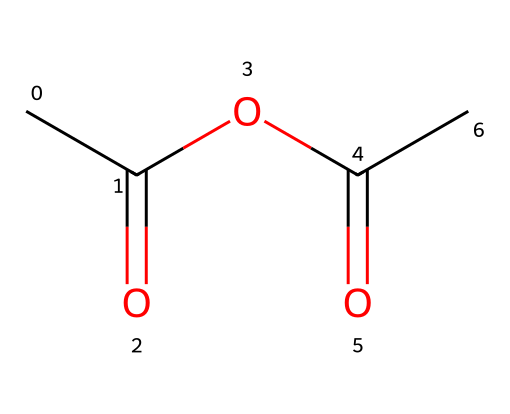What is the molecular formula of acetic anhydride? The chemical is represented by the provided SMILES, which shows there are 4 carbon atoms (C), 6 hydrogen atoms (H), and 3 oxygen atoms (O) present. The formula can be determined as C4H6O3.
Answer: C4H6O3 How many carbon atoms are in acetic anhydride? The SMILES structure indicates there are 4 carbon atoms (C) present in the chemical, as counted from the structure.
Answer: 4 What type of chemical bond is primarily observed in acetic anhydride? The structure shows that acetic anhydride contains both single and double bonds (specifically C=O and C-C). The most significant bond type in this chemical is the carbonyl bond (C=O).
Answer: carbonyl bond What is the significance of the functional group present in acetic anhydride? Acetic anhydride consists of an anhydride functional group, which is characterized by the presence of two acyl groups (RCO) bonded to the same oxygen atom. This functional group's presence is key for its reactivity, particularly in acylation reactions.
Answer: anhydride Is acetic anhydride soluble in water? Acetic anhydride has a polar structure due to its carbonyl groups, which allows for partial solubility in water, but it is generally known to have limited solubility compared to more polar substances.
Answer: limited solubility How many oxygen atoms are present in acetic anhydride? The structural formula indicates there are 3 oxygen atoms in acetic anhydride, identifiable from the SMILES representation.
Answer: 3 